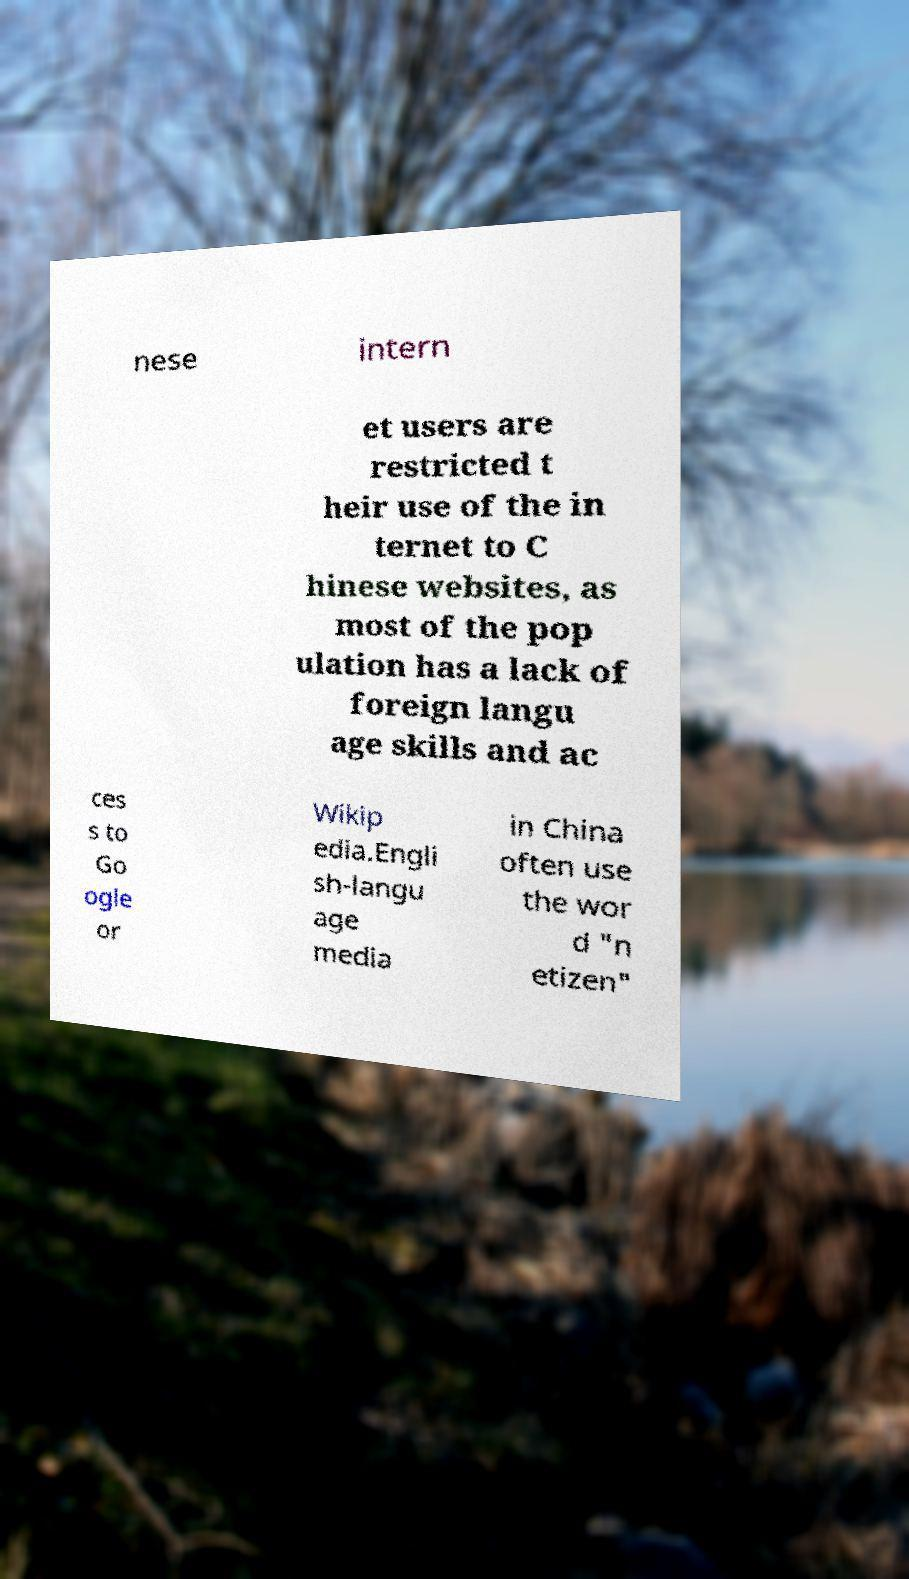Could you assist in decoding the text presented in this image and type it out clearly? nese intern et users are restricted t heir use of the in ternet to C hinese websites, as most of the pop ulation has a lack of foreign langu age skills and ac ces s to Go ogle or Wikip edia.Engli sh-langu age media in China often use the wor d "n etizen" 